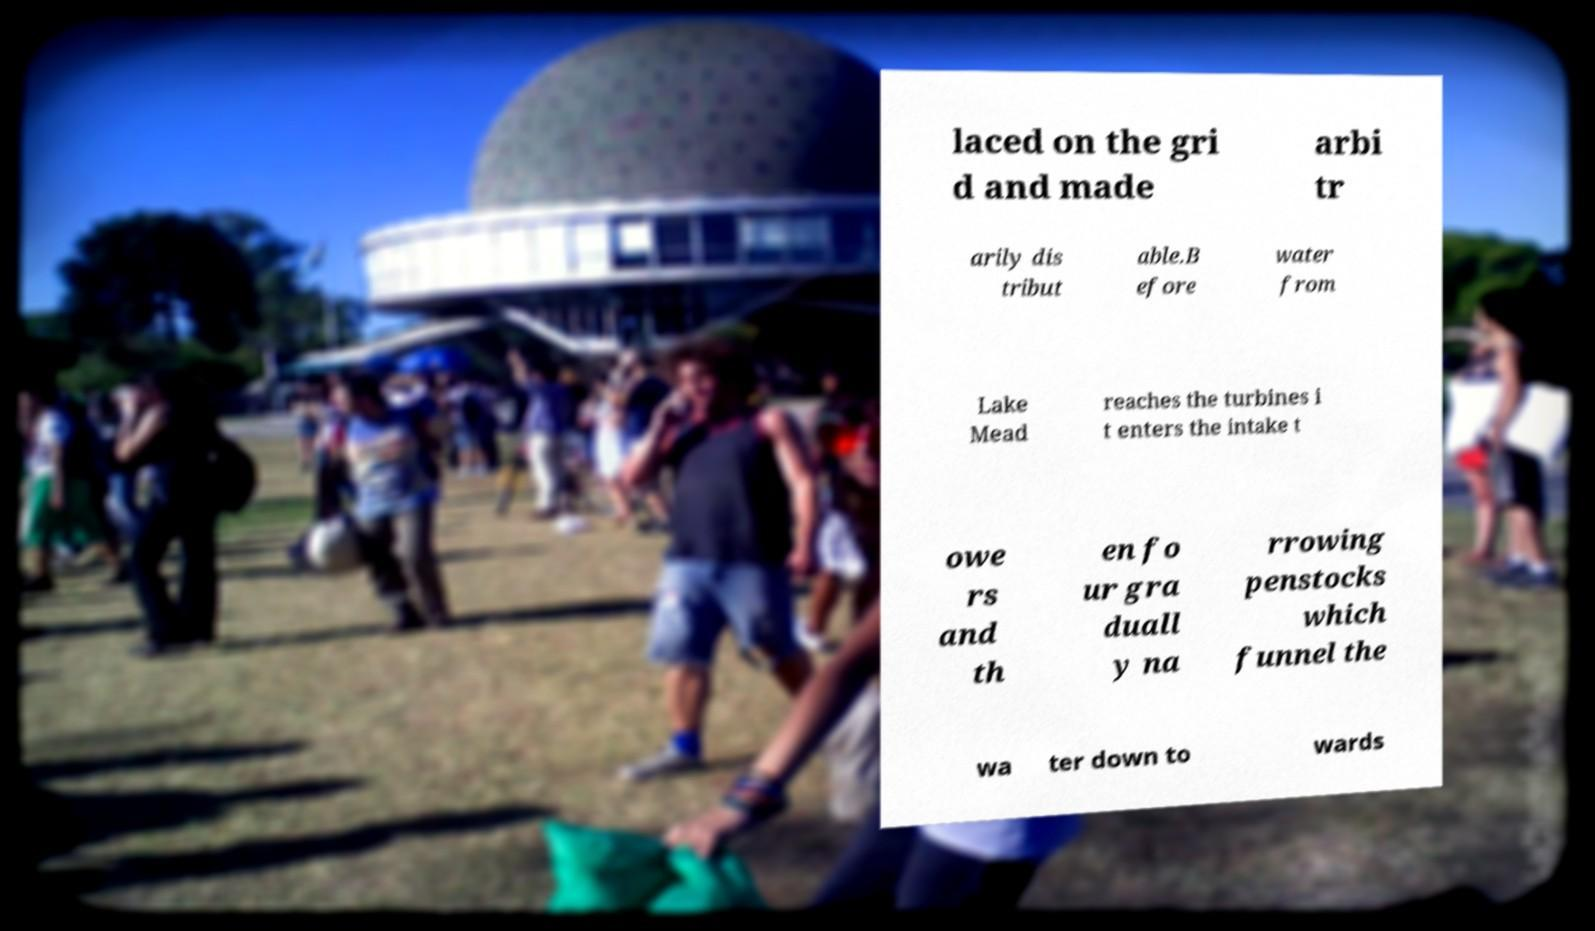Please identify and transcribe the text found in this image. laced on the gri d and made arbi tr arily dis tribut able.B efore water from Lake Mead reaches the turbines i t enters the intake t owe rs and th en fo ur gra duall y na rrowing penstocks which funnel the wa ter down to wards 